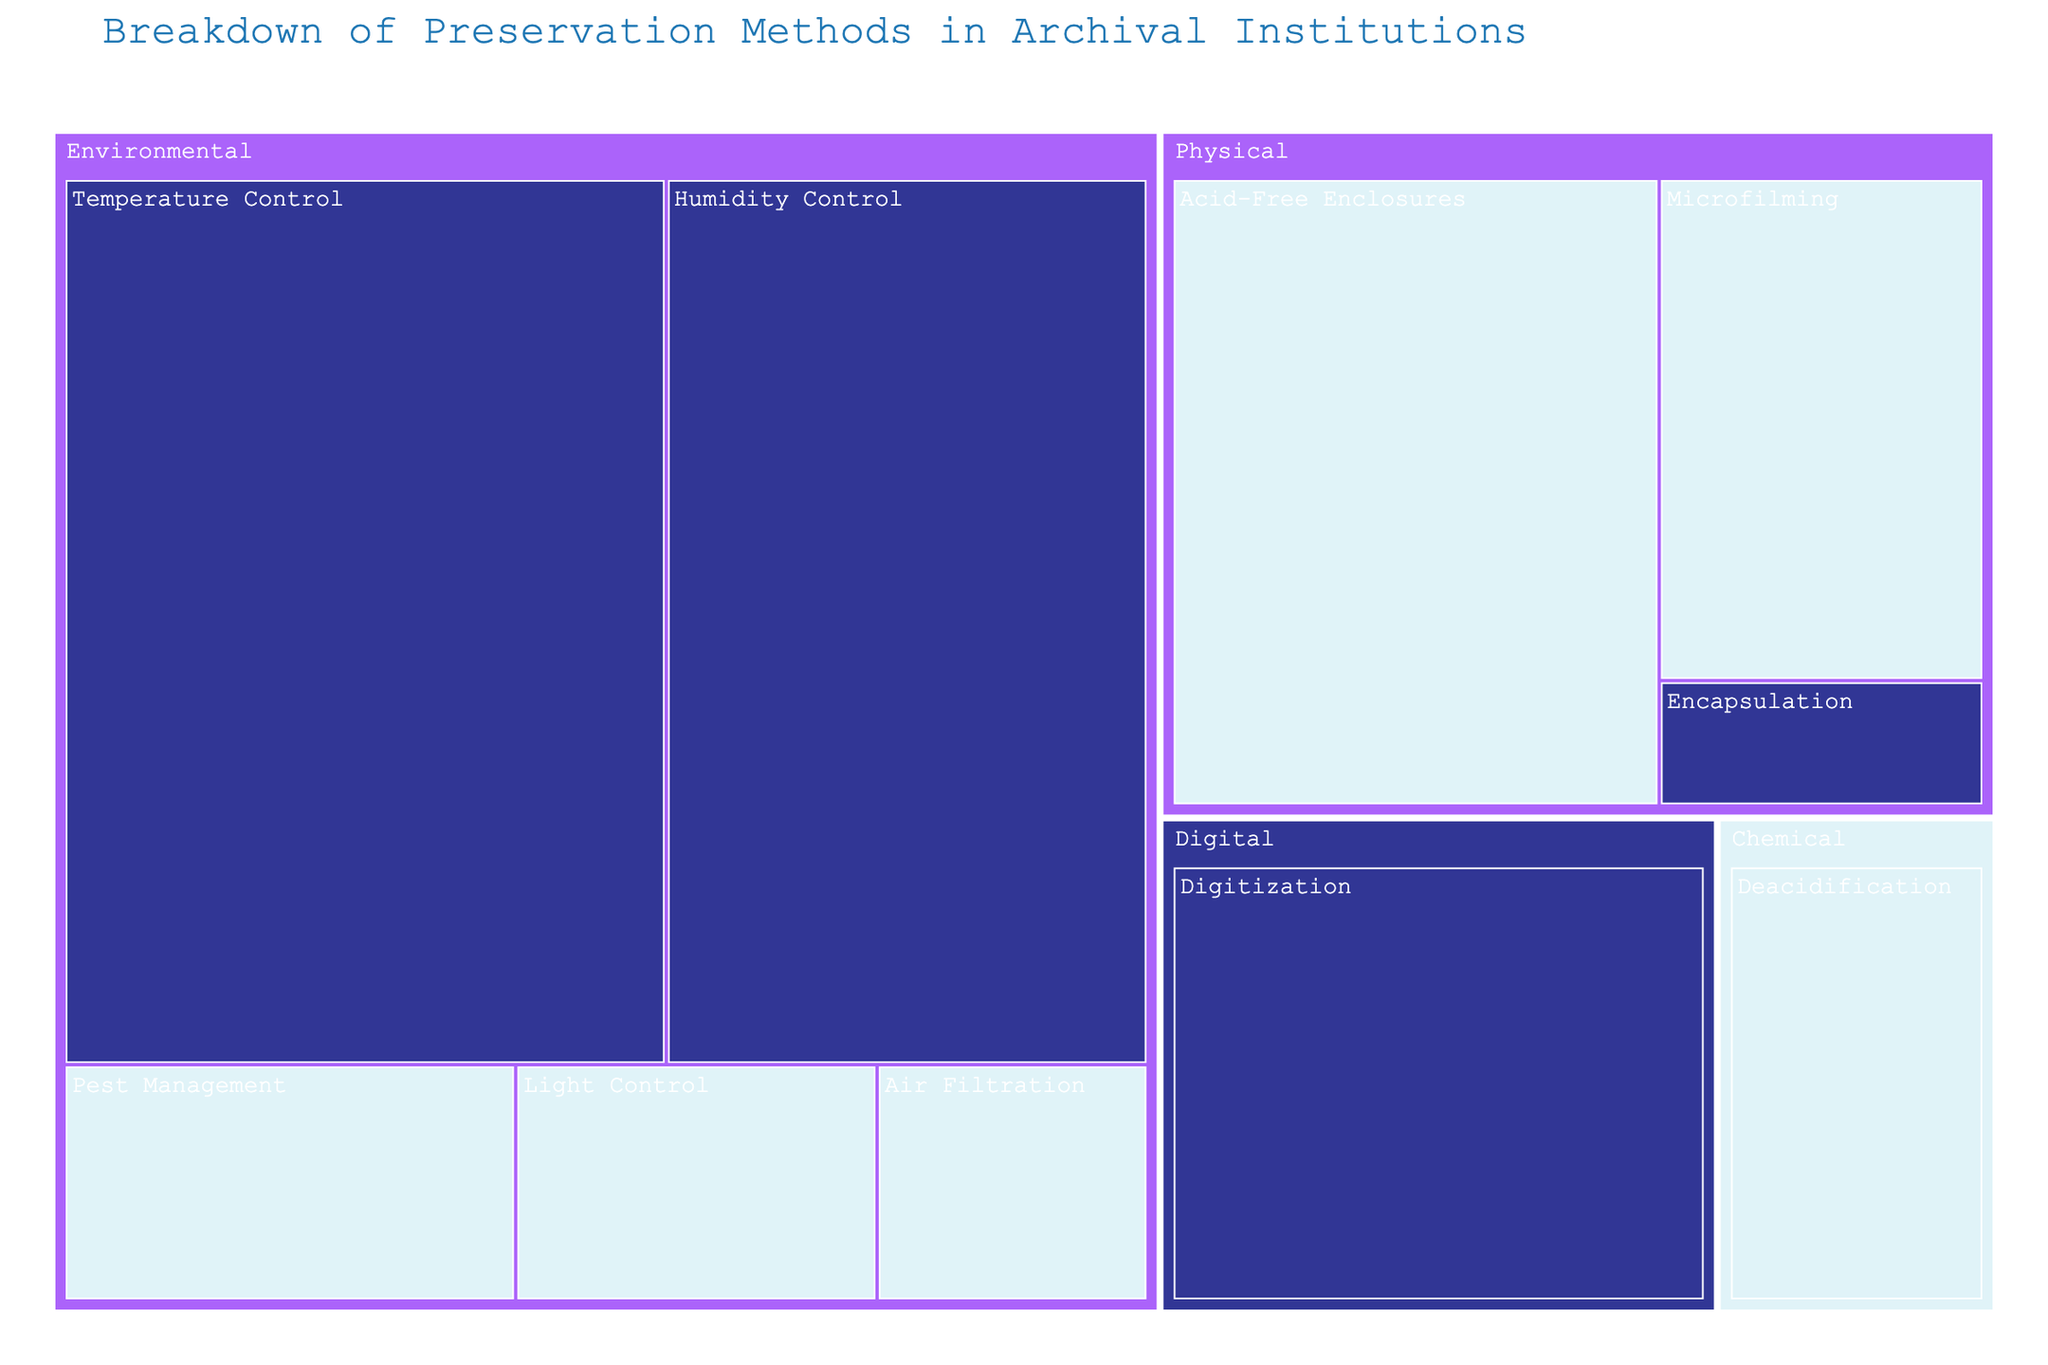What is the title of the figure? The title is usually prominently displayed at the top of the figure. By simply reading the text at the top, we can identify the title.
Answer: Breakdown of Preservation Methods in Archival Institutions Which preservation method has the highest usage percentage? The treemap clearly distinguishes the size of each section based on their usage percentage. The largest section represents the method with the highest usage percentage.
Answer: Temperature Control How many preservation methods are classified as "Environmental"? "Environmental" is a type category in the treemap. By visually inspecting the sub-sections under "Environmental," we count them.
Answer: 5 What is the difference in usage percentage between the preservation method with the highest and the lowest effectiveness within the "Physical" type? First, identify the "Physical" type and locate methods with their effectiveness levels and usage percentages. Subtract the usage percentage of the method with the lowest effectiveness from the one with the highest. Encapsulation has the highest effectiveness with a usage of 2%, and Microfilming has a medium effectiveness with a usage of 8%. The difference is 8% - 2%.
Answer: 6% Which "Chemical" preservation method is shown on the treemap? Within the treemap, locate the section that falls under the "Chemical" category and read the label inside it.
Answer: Deacidification Compare the size of the sections for Digitization and Acid-Free Enclosures. Which one is larger? Locate the sections for Digitization and Acid-Free Enclosures. Compare their sizes based on area, as larger usage percentages occupy more space.
Answer: Acid-Free Enclosures Rank the “Environmental” preservation methods based on their effectiveness and usage percentage from highest to lowest. Identify the effectiveness and usage percentages of each "Environmental" preservation method, and then list them in descending order of both criteria. Temperature Control (High, 25%), Humidity Control (High, 20%), Pest Management (Medium, 5%), Light Control (Medium, 4%), Air Filtration (Medium, 3%).
Answer: Temperature Control > Humidity Control > Pest Management > Light Control > Air Filtration Which preservation methods are marked with "Medium" effectiveness? Visually locate all sections labeled with "Medium" effectiveness in the treemap. Identify and list the preservation methods.
Answer: Acid-Free Enclosures, Microfilming, Deacidification, Pest Management, Light Control, Air Filtration What is the combined usage percentage of all "Digital" preservation methods? Identify the section for "Digital" type preservation methods. In this case, it's only Digitization. Thus, the usage percentage is 12%.
Answer: 12% 